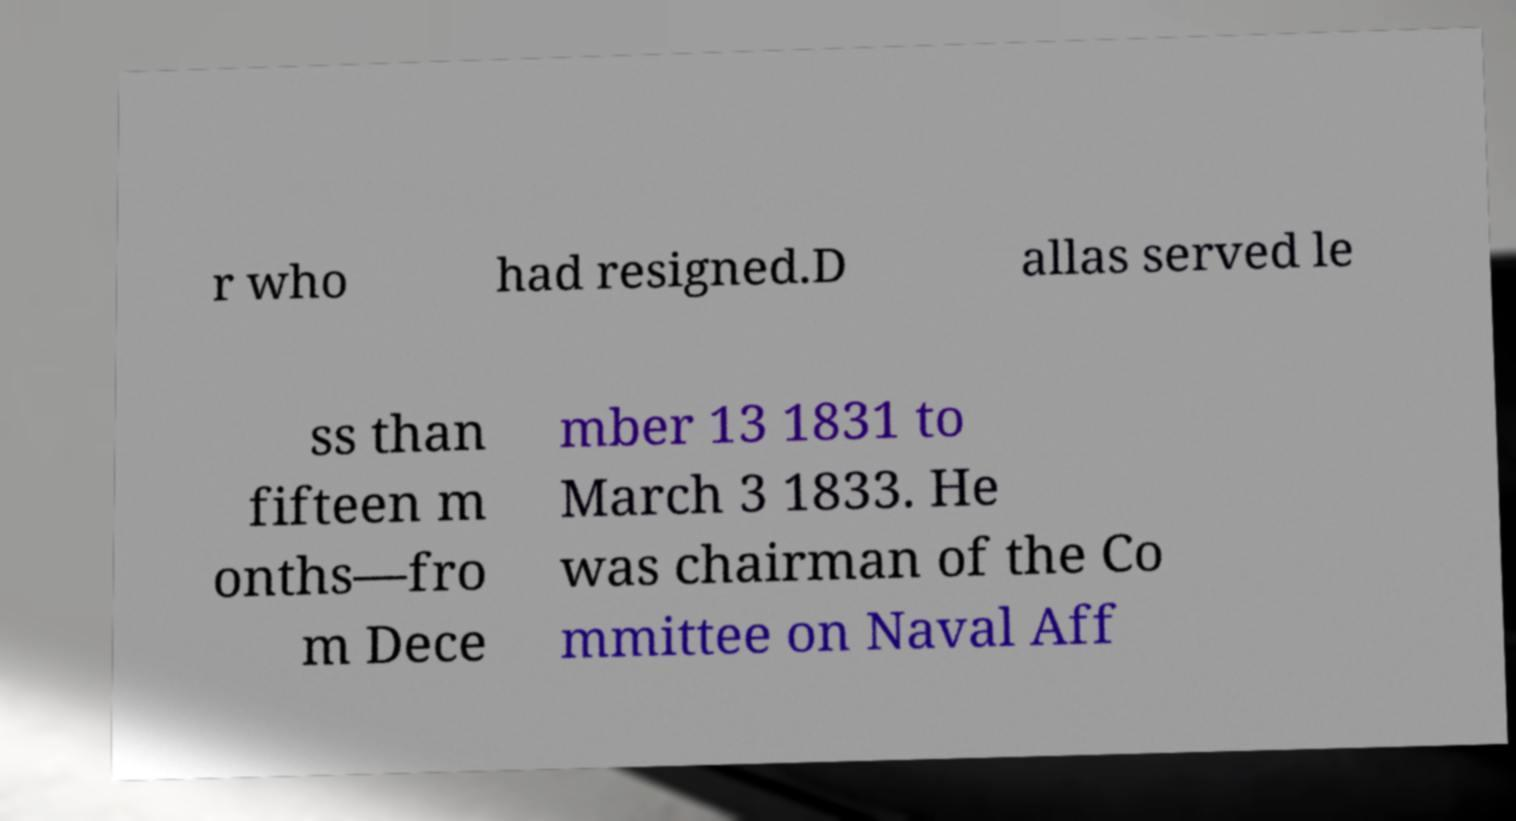There's text embedded in this image that I need extracted. Can you transcribe it verbatim? r who had resigned.D allas served le ss than fifteen m onths—fro m Dece mber 13 1831 to March 3 1833. He was chairman of the Co mmittee on Naval Aff 